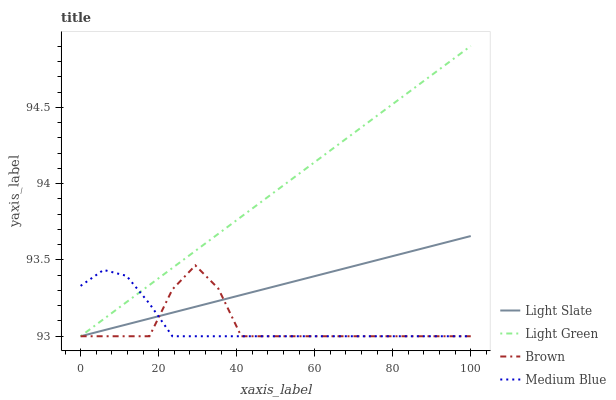Does Medium Blue have the minimum area under the curve?
Answer yes or no. No. Does Medium Blue have the maximum area under the curve?
Answer yes or no. No. Is Medium Blue the smoothest?
Answer yes or no. No. Is Medium Blue the roughest?
Answer yes or no. No. Does Brown have the highest value?
Answer yes or no. No. 